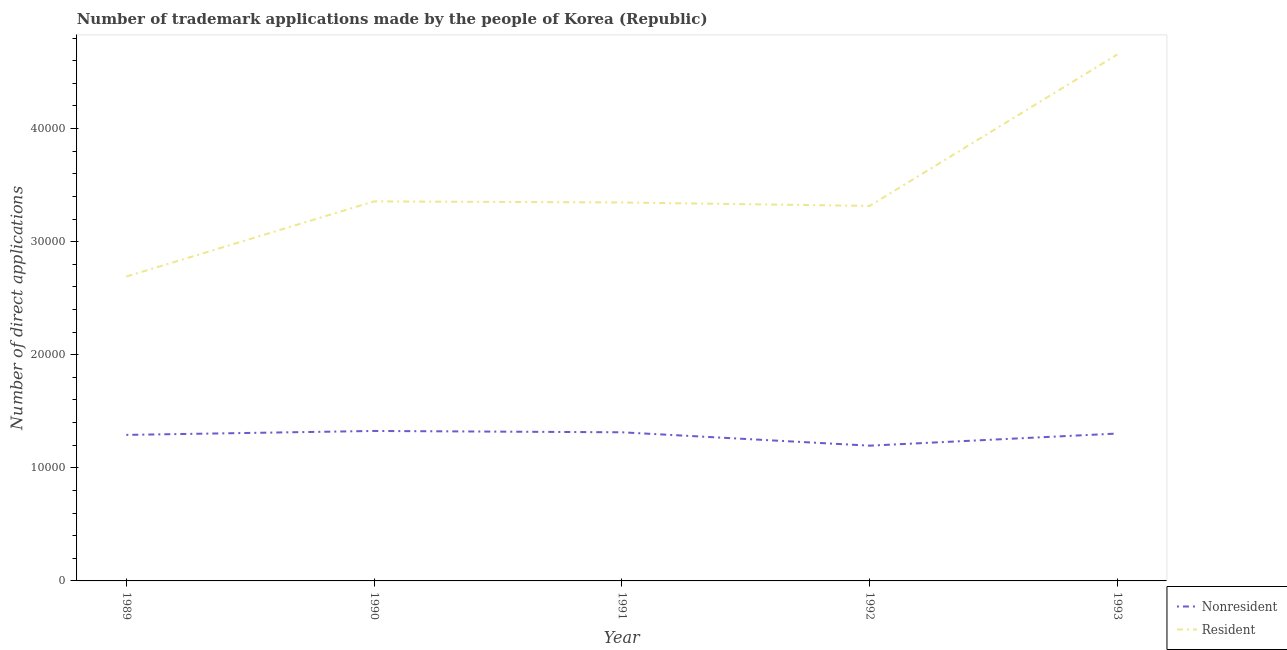How many different coloured lines are there?
Your answer should be compact. 2. Does the line corresponding to number of trademark applications made by non residents intersect with the line corresponding to number of trademark applications made by residents?
Offer a very short reply. No. What is the number of trademark applications made by residents in 1993?
Keep it short and to the point. 4.66e+04. Across all years, what is the maximum number of trademark applications made by residents?
Provide a short and direct response. 4.66e+04. Across all years, what is the minimum number of trademark applications made by residents?
Your answer should be very brief. 2.69e+04. What is the total number of trademark applications made by residents in the graph?
Provide a succinct answer. 1.74e+05. What is the difference between the number of trademark applications made by residents in 1990 and that in 1992?
Your response must be concise. 401. What is the difference between the number of trademark applications made by residents in 1989 and the number of trademark applications made by non residents in 1992?
Offer a terse response. 1.50e+04. What is the average number of trademark applications made by non residents per year?
Provide a short and direct response. 1.29e+04. In the year 1992, what is the difference between the number of trademark applications made by residents and number of trademark applications made by non residents?
Your answer should be compact. 2.12e+04. In how many years, is the number of trademark applications made by non residents greater than 2000?
Provide a short and direct response. 5. What is the ratio of the number of trademark applications made by non residents in 1992 to that in 1993?
Your answer should be very brief. 0.92. What is the difference between the highest and the second highest number of trademark applications made by non residents?
Your answer should be compact. 118. What is the difference between the highest and the lowest number of trademark applications made by non residents?
Give a very brief answer. 1301. In how many years, is the number of trademark applications made by non residents greater than the average number of trademark applications made by non residents taken over all years?
Ensure brevity in your answer.  4. Is the sum of the number of trademark applications made by non residents in 1990 and 1993 greater than the maximum number of trademark applications made by residents across all years?
Provide a succinct answer. No. Does the number of trademark applications made by residents monotonically increase over the years?
Keep it short and to the point. No. How many years are there in the graph?
Offer a terse response. 5. Are the values on the major ticks of Y-axis written in scientific E-notation?
Keep it short and to the point. No. Does the graph contain any zero values?
Your answer should be very brief. No. Does the graph contain grids?
Your response must be concise. No. Where does the legend appear in the graph?
Give a very brief answer. Bottom right. How are the legend labels stacked?
Your answer should be compact. Vertical. What is the title of the graph?
Provide a short and direct response. Number of trademark applications made by the people of Korea (Republic). What is the label or title of the Y-axis?
Keep it short and to the point. Number of direct applications. What is the Number of direct applications of Nonresident in 1989?
Offer a terse response. 1.29e+04. What is the Number of direct applications of Resident in 1989?
Your answer should be compact. 2.69e+04. What is the Number of direct applications in Nonresident in 1990?
Your answer should be very brief. 1.33e+04. What is the Number of direct applications in Resident in 1990?
Offer a terse response. 3.36e+04. What is the Number of direct applications of Nonresident in 1991?
Make the answer very short. 1.31e+04. What is the Number of direct applications in Resident in 1991?
Provide a short and direct response. 3.35e+04. What is the Number of direct applications of Nonresident in 1992?
Your answer should be very brief. 1.20e+04. What is the Number of direct applications in Resident in 1992?
Make the answer very short. 3.32e+04. What is the Number of direct applications in Nonresident in 1993?
Ensure brevity in your answer.  1.30e+04. What is the Number of direct applications of Resident in 1993?
Make the answer very short. 4.66e+04. Across all years, what is the maximum Number of direct applications in Nonresident?
Ensure brevity in your answer.  1.33e+04. Across all years, what is the maximum Number of direct applications of Resident?
Provide a succinct answer. 4.66e+04. Across all years, what is the minimum Number of direct applications in Nonresident?
Your answer should be very brief. 1.20e+04. Across all years, what is the minimum Number of direct applications of Resident?
Provide a succinct answer. 2.69e+04. What is the total Number of direct applications of Nonresident in the graph?
Offer a terse response. 6.43e+04. What is the total Number of direct applications in Resident in the graph?
Your answer should be compact. 1.74e+05. What is the difference between the Number of direct applications of Nonresident in 1989 and that in 1990?
Keep it short and to the point. -348. What is the difference between the Number of direct applications of Resident in 1989 and that in 1990?
Your answer should be compact. -6646. What is the difference between the Number of direct applications of Nonresident in 1989 and that in 1991?
Ensure brevity in your answer.  -230. What is the difference between the Number of direct applications of Resident in 1989 and that in 1991?
Provide a short and direct response. -6550. What is the difference between the Number of direct applications in Nonresident in 1989 and that in 1992?
Make the answer very short. 953. What is the difference between the Number of direct applications of Resident in 1989 and that in 1992?
Keep it short and to the point. -6245. What is the difference between the Number of direct applications of Nonresident in 1989 and that in 1993?
Your response must be concise. -120. What is the difference between the Number of direct applications in Resident in 1989 and that in 1993?
Give a very brief answer. -1.96e+04. What is the difference between the Number of direct applications of Nonresident in 1990 and that in 1991?
Give a very brief answer. 118. What is the difference between the Number of direct applications in Resident in 1990 and that in 1991?
Offer a very short reply. 96. What is the difference between the Number of direct applications in Nonresident in 1990 and that in 1992?
Your answer should be compact. 1301. What is the difference between the Number of direct applications of Resident in 1990 and that in 1992?
Offer a very short reply. 401. What is the difference between the Number of direct applications of Nonresident in 1990 and that in 1993?
Make the answer very short. 228. What is the difference between the Number of direct applications in Resident in 1990 and that in 1993?
Offer a terse response. -1.30e+04. What is the difference between the Number of direct applications of Nonresident in 1991 and that in 1992?
Offer a terse response. 1183. What is the difference between the Number of direct applications of Resident in 1991 and that in 1992?
Keep it short and to the point. 305. What is the difference between the Number of direct applications of Nonresident in 1991 and that in 1993?
Offer a very short reply. 110. What is the difference between the Number of direct applications in Resident in 1991 and that in 1993?
Ensure brevity in your answer.  -1.31e+04. What is the difference between the Number of direct applications of Nonresident in 1992 and that in 1993?
Your answer should be very brief. -1073. What is the difference between the Number of direct applications of Resident in 1992 and that in 1993?
Provide a short and direct response. -1.34e+04. What is the difference between the Number of direct applications in Nonresident in 1989 and the Number of direct applications in Resident in 1990?
Offer a very short reply. -2.06e+04. What is the difference between the Number of direct applications of Nonresident in 1989 and the Number of direct applications of Resident in 1991?
Offer a very short reply. -2.06e+04. What is the difference between the Number of direct applications of Nonresident in 1989 and the Number of direct applications of Resident in 1992?
Provide a short and direct response. -2.02e+04. What is the difference between the Number of direct applications in Nonresident in 1989 and the Number of direct applications in Resident in 1993?
Provide a short and direct response. -3.36e+04. What is the difference between the Number of direct applications of Nonresident in 1990 and the Number of direct applications of Resident in 1991?
Offer a terse response. -2.02e+04. What is the difference between the Number of direct applications of Nonresident in 1990 and the Number of direct applications of Resident in 1992?
Your response must be concise. -1.99e+04. What is the difference between the Number of direct applications in Nonresident in 1990 and the Number of direct applications in Resident in 1993?
Give a very brief answer. -3.33e+04. What is the difference between the Number of direct applications of Nonresident in 1991 and the Number of direct applications of Resident in 1992?
Keep it short and to the point. -2.00e+04. What is the difference between the Number of direct applications in Nonresident in 1991 and the Number of direct applications in Resident in 1993?
Your answer should be compact. -3.34e+04. What is the difference between the Number of direct applications of Nonresident in 1992 and the Number of direct applications of Resident in 1993?
Your response must be concise. -3.46e+04. What is the average Number of direct applications in Nonresident per year?
Provide a succinct answer. 1.29e+04. What is the average Number of direct applications of Resident per year?
Make the answer very short. 3.47e+04. In the year 1989, what is the difference between the Number of direct applications in Nonresident and Number of direct applications in Resident?
Provide a short and direct response. -1.40e+04. In the year 1990, what is the difference between the Number of direct applications in Nonresident and Number of direct applications in Resident?
Give a very brief answer. -2.03e+04. In the year 1991, what is the difference between the Number of direct applications in Nonresident and Number of direct applications in Resident?
Your response must be concise. -2.03e+04. In the year 1992, what is the difference between the Number of direct applications of Nonresident and Number of direct applications of Resident?
Your response must be concise. -2.12e+04. In the year 1993, what is the difference between the Number of direct applications in Nonresident and Number of direct applications in Resident?
Your answer should be very brief. -3.35e+04. What is the ratio of the Number of direct applications in Nonresident in 1989 to that in 1990?
Provide a succinct answer. 0.97. What is the ratio of the Number of direct applications of Resident in 1989 to that in 1990?
Ensure brevity in your answer.  0.8. What is the ratio of the Number of direct applications of Nonresident in 1989 to that in 1991?
Offer a very short reply. 0.98. What is the ratio of the Number of direct applications in Resident in 1989 to that in 1991?
Provide a succinct answer. 0.8. What is the ratio of the Number of direct applications of Nonresident in 1989 to that in 1992?
Your answer should be compact. 1.08. What is the ratio of the Number of direct applications of Resident in 1989 to that in 1992?
Make the answer very short. 0.81. What is the ratio of the Number of direct applications in Nonresident in 1989 to that in 1993?
Keep it short and to the point. 0.99. What is the ratio of the Number of direct applications of Resident in 1989 to that in 1993?
Your answer should be compact. 0.58. What is the ratio of the Number of direct applications in Nonresident in 1990 to that in 1991?
Offer a very short reply. 1.01. What is the ratio of the Number of direct applications of Resident in 1990 to that in 1991?
Offer a very short reply. 1. What is the ratio of the Number of direct applications of Nonresident in 1990 to that in 1992?
Your answer should be compact. 1.11. What is the ratio of the Number of direct applications of Resident in 1990 to that in 1992?
Give a very brief answer. 1.01. What is the ratio of the Number of direct applications in Nonresident in 1990 to that in 1993?
Make the answer very short. 1.02. What is the ratio of the Number of direct applications in Resident in 1990 to that in 1993?
Make the answer very short. 0.72. What is the ratio of the Number of direct applications in Nonresident in 1991 to that in 1992?
Provide a succinct answer. 1.1. What is the ratio of the Number of direct applications in Resident in 1991 to that in 1992?
Your answer should be compact. 1.01. What is the ratio of the Number of direct applications of Nonresident in 1991 to that in 1993?
Give a very brief answer. 1.01. What is the ratio of the Number of direct applications of Resident in 1991 to that in 1993?
Ensure brevity in your answer.  0.72. What is the ratio of the Number of direct applications of Nonresident in 1992 to that in 1993?
Make the answer very short. 0.92. What is the ratio of the Number of direct applications of Resident in 1992 to that in 1993?
Your answer should be very brief. 0.71. What is the difference between the highest and the second highest Number of direct applications of Nonresident?
Make the answer very short. 118. What is the difference between the highest and the second highest Number of direct applications of Resident?
Give a very brief answer. 1.30e+04. What is the difference between the highest and the lowest Number of direct applications in Nonresident?
Your answer should be very brief. 1301. What is the difference between the highest and the lowest Number of direct applications of Resident?
Make the answer very short. 1.96e+04. 